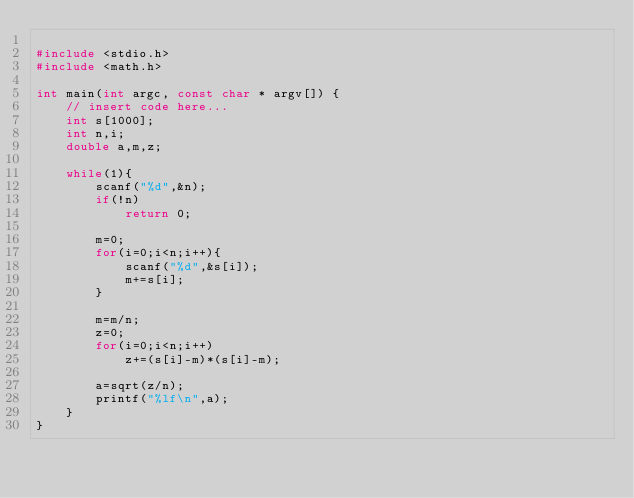Convert code to text. <code><loc_0><loc_0><loc_500><loc_500><_C_>
#include <stdio.h>
#include <math.h>

int main(int argc, const char * argv[]) {
    // insert code here...
    int s[1000];
    int n,i;
    double a,m,z;
    
    while(1){
        scanf("%d",&n);
        if(!n)
            return 0;
        
        m=0;
        for(i=0;i<n;i++){
            scanf("%d",&s[i]);
            m+=s[i];
        }
        
        m=m/n;
        z=0;
        for(i=0;i<n;i++)
            z+=(s[i]-m)*(s[i]-m);
        
        a=sqrt(z/n);
        printf("%lf\n",a);
    }
}</code> 